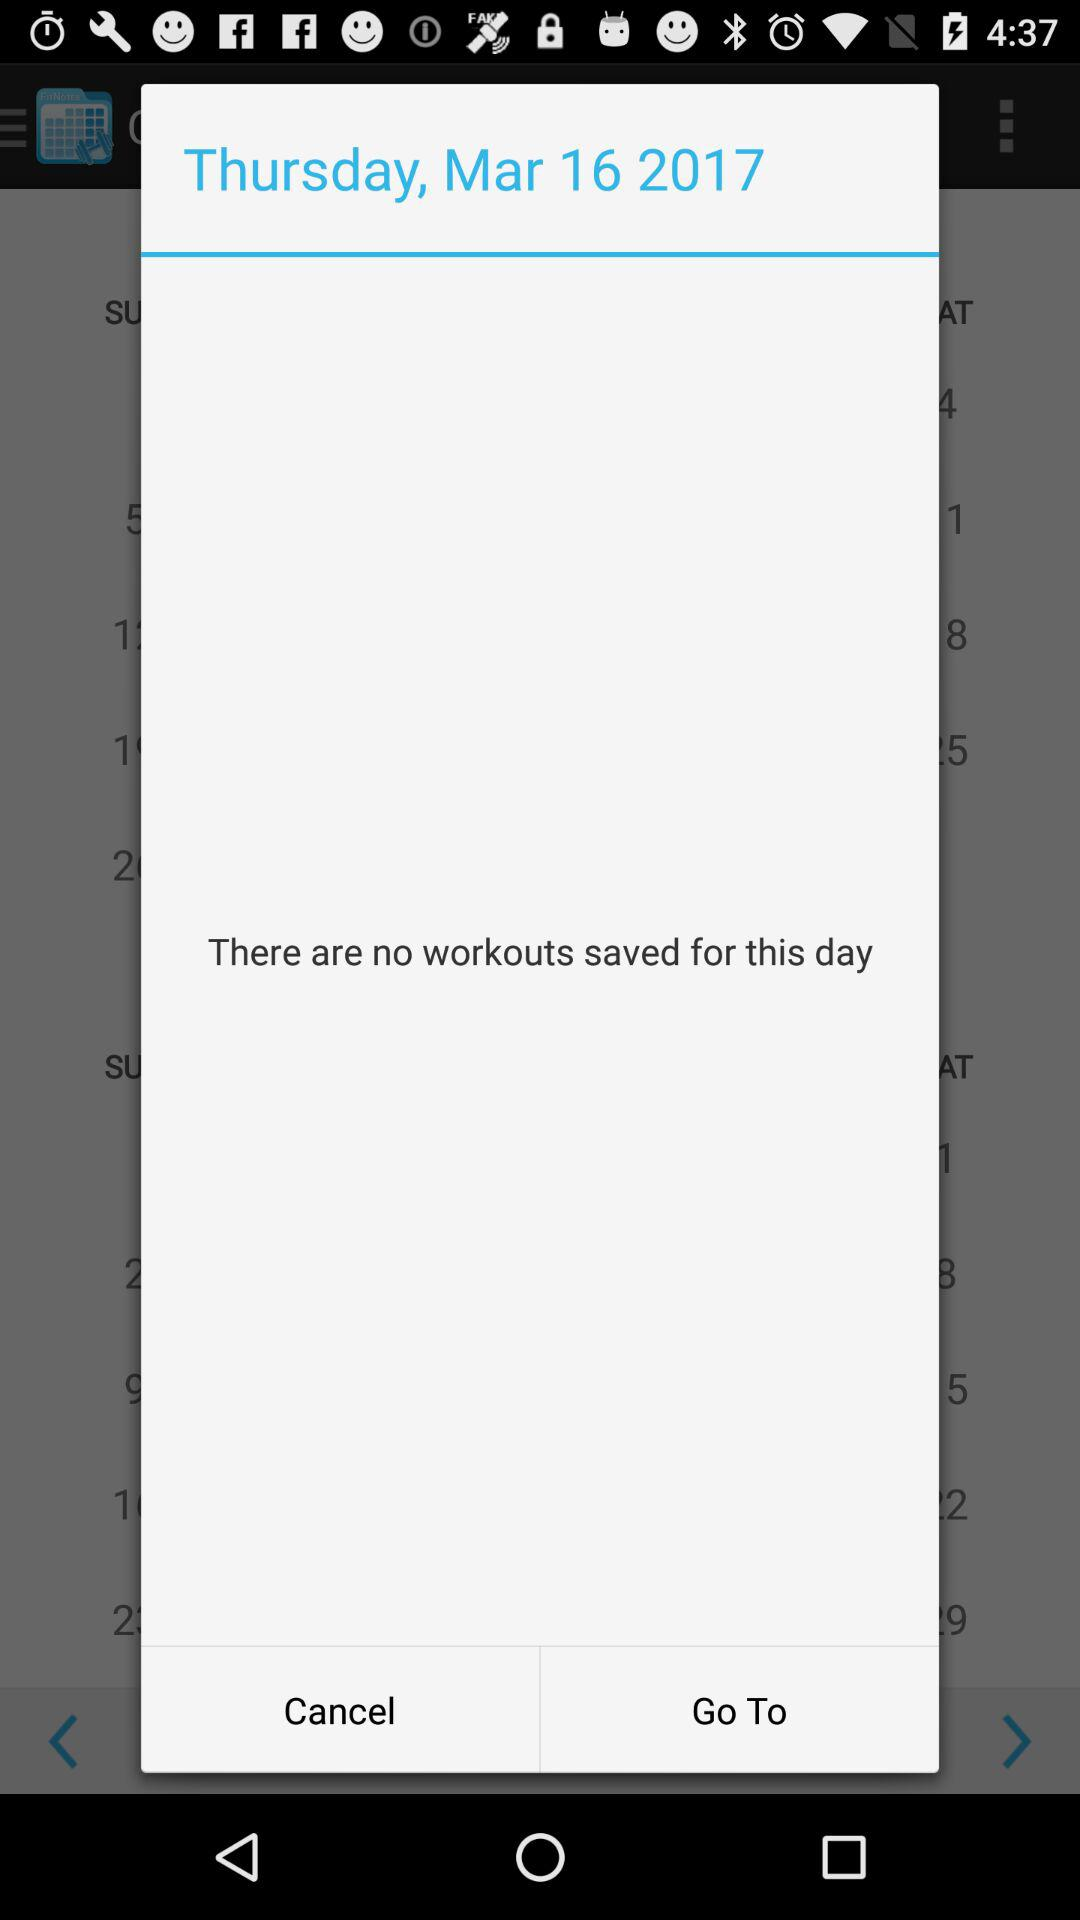Is there any workout saved for this day? There are no workouts saved for this day. 